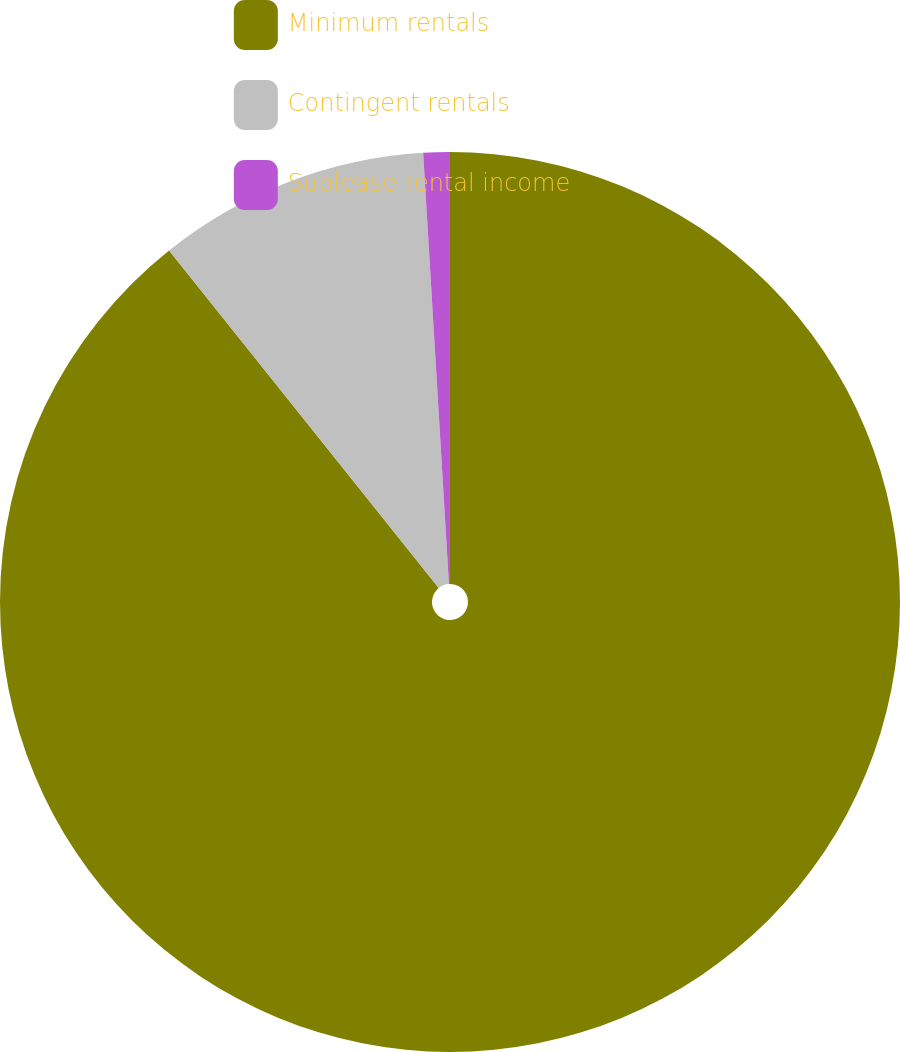Convert chart. <chart><loc_0><loc_0><loc_500><loc_500><pie_chart><fcel>Minimum rentals<fcel>Contingent rentals<fcel>Sublease rental income<nl><fcel>89.27%<fcel>9.78%<fcel>0.95%<nl></chart> 